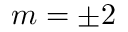Convert formula to latex. <formula><loc_0><loc_0><loc_500><loc_500>m = \pm 2</formula> 